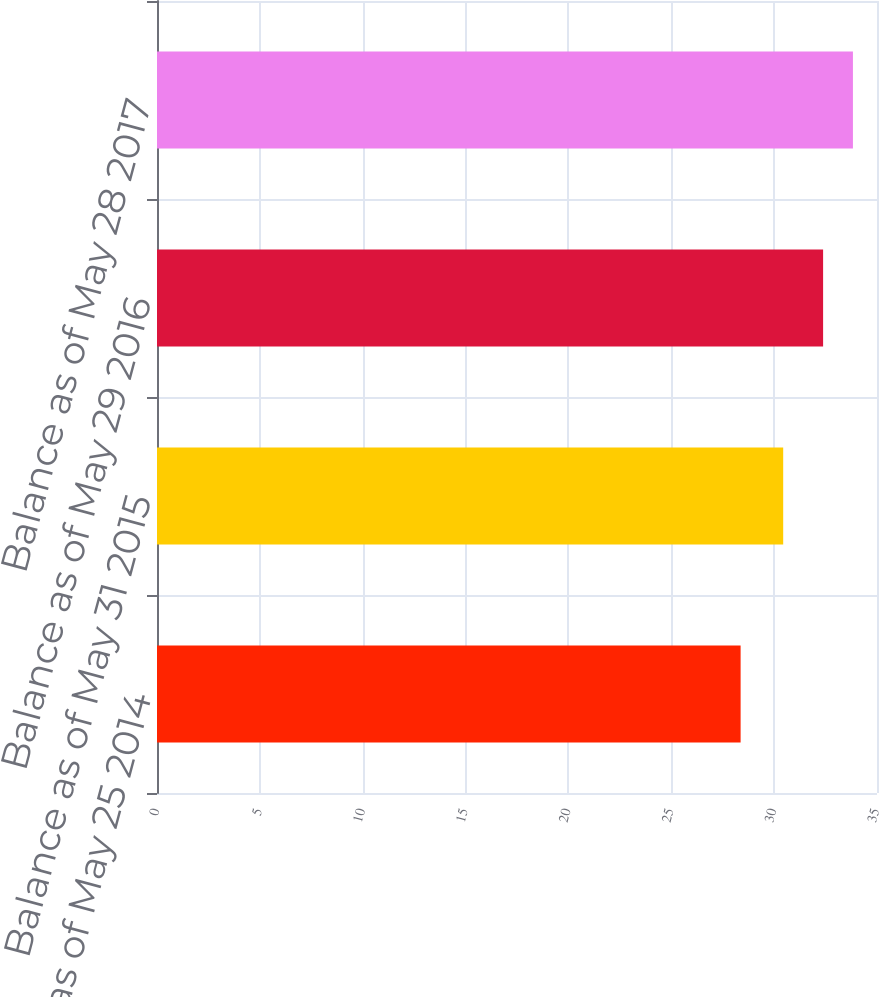Convert chart to OTSL. <chart><loc_0><loc_0><loc_500><loc_500><bar_chart><fcel>Balance as of May 25 2014<fcel>Balance as of May 31 2015<fcel>Balance as of May 29 2016<fcel>Balance as of May 28 2017<nl><fcel>28.37<fcel>30.44<fcel>32.38<fcel>33.83<nl></chart> 